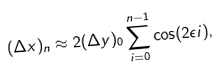<formula> <loc_0><loc_0><loc_500><loc_500>( \Delta x ) _ { n } \approx 2 ( \Delta y ) _ { 0 } \sum _ { i = 0 } ^ { n - 1 } \cos ( 2 \epsilon i ) ,</formula> 